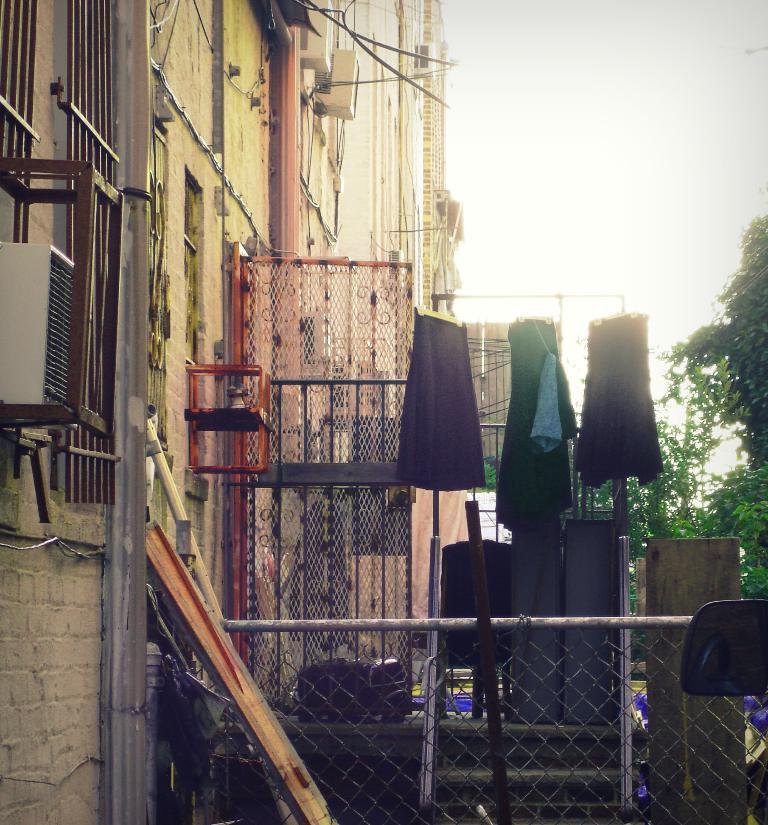How would you summarize this image in a sentence or two? In this picture I can see buildings and few trees and few clothes and I can see a metal fence and couple of wooden planks and I can see a cloudy sky. 